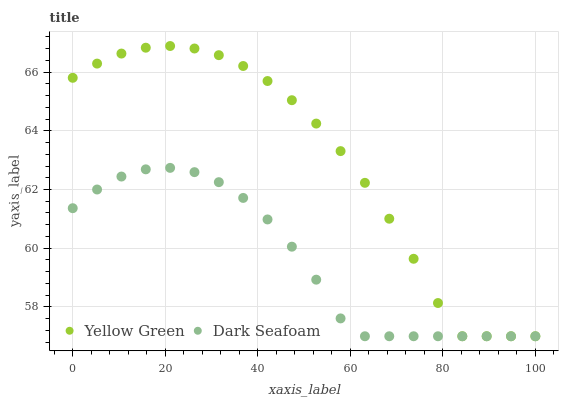Does Dark Seafoam have the minimum area under the curve?
Answer yes or no. Yes. Does Yellow Green have the maximum area under the curve?
Answer yes or no. Yes. Does Yellow Green have the minimum area under the curve?
Answer yes or no. No. Is Dark Seafoam the smoothest?
Answer yes or no. Yes. Is Yellow Green the roughest?
Answer yes or no. Yes. Is Yellow Green the smoothest?
Answer yes or no. No. Does Dark Seafoam have the lowest value?
Answer yes or no. Yes. Does Yellow Green have the highest value?
Answer yes or no. Yes. Does Dark Seafoam intersect Yellow Green?
Answer yes or no. Yes. Is Dark Seafoam less than Yellow Green?
Answer yes or no. No. Is Dark Seafoam greater than Yellow Green?
Answer yes or no. No. 